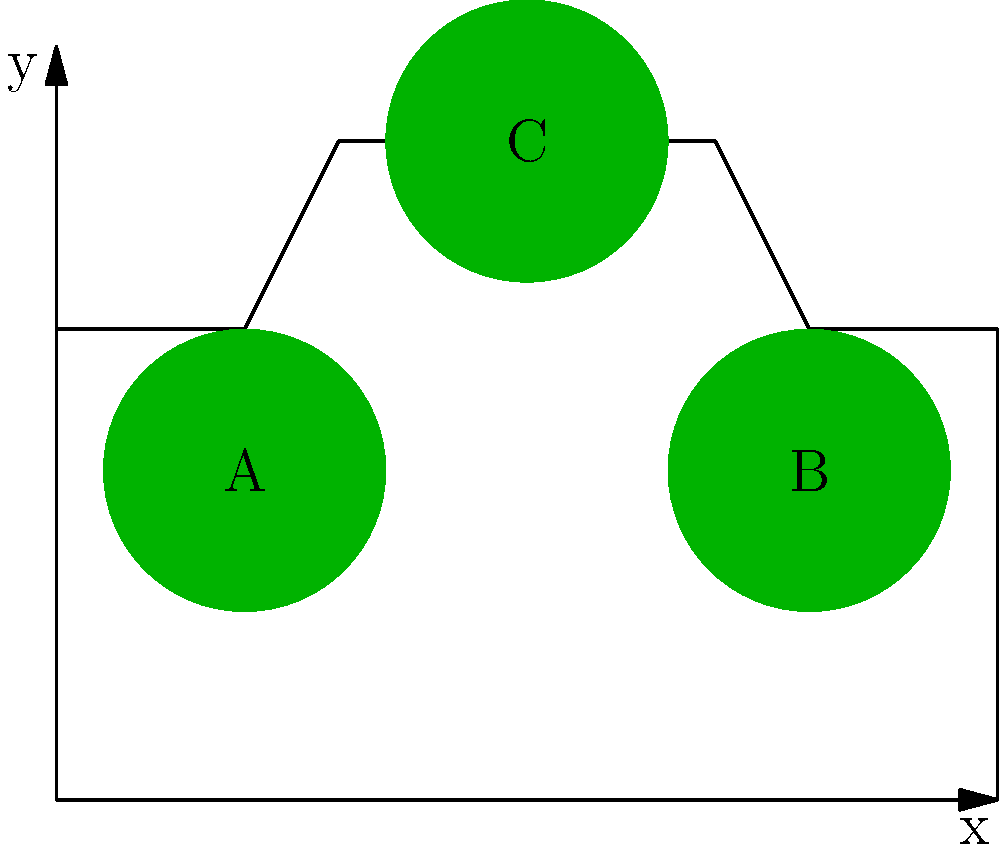In the diagram above, which impact zone (A, B, or C) would likely require the least amount of additional safety features based on its location and existing vehicle structure? To answer this question, we need to consider the following factors:

1. Location of impact zones:
   A: Front side
   B: Rear side
   C: Top/roof

2. Existing vehicle structures:
   - The front and rear of vehicles typically have crumple zones designed to absorb impact.
   - The sides of vehicles often have reinforced door beams.
   - The roof has structural support pillars.

3. Analysis of each zone:
   A: Front side - Already has crumple zones and engine compartment to absorb impact.
   B: Rear side - Similar to front, has crumple zones and trunk space for impact absorption.
   C: Top/roof - Relies mainly on roof pillars for structural integrity.

4. Conclusion:
   Zone C (roof) would likely require the most additional safety features, as it has less existing structural support compared to the front and rear zones.

Therefore, either A or B would require the least amount of additional safety features. However, as a car manufacturer lobbyist, we might emphasize that B (rear side) typically has fewer critical components and passengers, making it the area requiring the least additional safety features.
Answer: B 